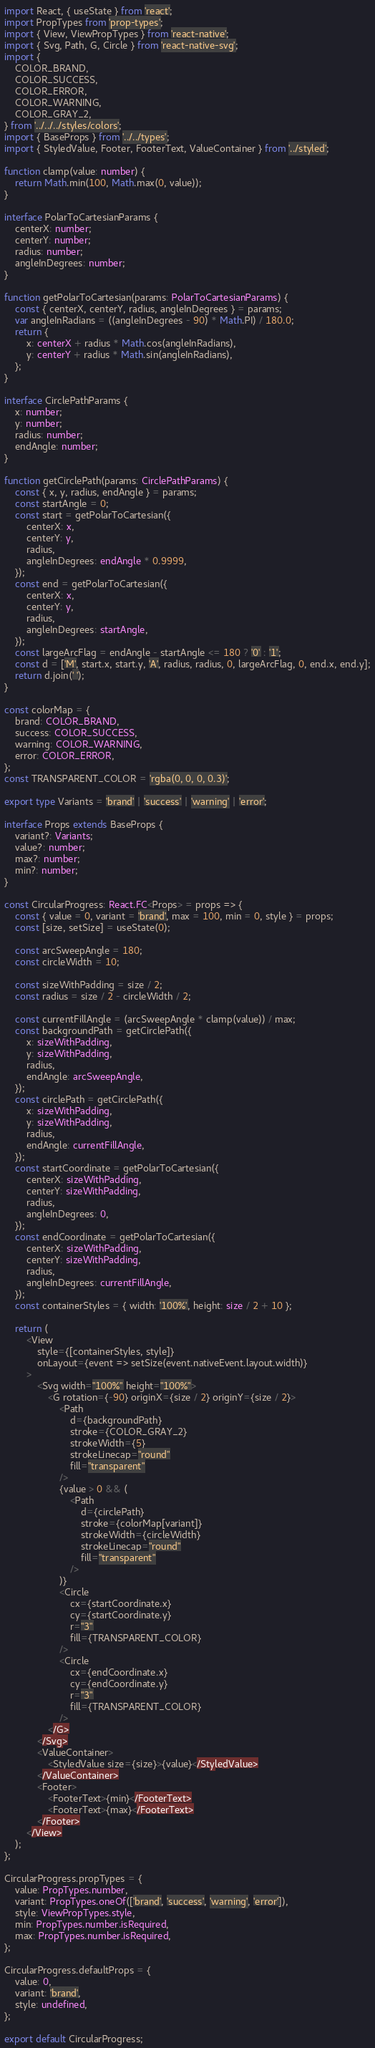<code> <loc_0><loc_0><loc_500><loc_500><_TypeScript_>import React, { useState } from 'react';
import PropTypes from 'prop-types';
import { View, ViewPropTypes } from 'react-native';
import { Svg, Path, G, Circle } from 'react-native-svg';
import {
    COLOR_BRAND,
    COLOR_SUCCESS,
    COLOR_ERROR,
    COLOR_WARNING,
    COLOR_GRAY_2,
} from '../../../styles/colors';
import { BaseProps } from '../../types';
import { StyledValue, Footer, FooterText, ValueContainer } from '../styled';

function clamp(value: number) {
    return Math.min(100, Math.max(0, value));
}

interface PolarToCartesianParams {
    centerX: number;
    centerY: number;
    radius: number;
    angleInDegrees: number;
}

function getPolarToCartesian(params: PolarToCartesianParams) {
    const { centerX, centerY, radius, angleInDegrees } = params;
    var angleInRadians = ((angleInDegrees - 90) * Math.PI) / 180.0;
    return {
        x: centerX + radius * Math.cos(angleInRadians),
        y: centerY + radius * Math.sin(angleInRadians),
    };
}

interface CirclePathParams {
    x: number;
    y: number;
    radius: number;
    endAngle: number;
}

function getCirclePath(params: CirclePathParams) {
    const { x, y, radius, endAngle } = params;
    const startAngle = 0;
    const start = getPolarToCartesian({
        centerX: x,
        centerY: y,
        radius,
        angleInDegrees: endAngle * 0.9999,
    });
    const end = getPolarToCartesian({
        centerX: x,
        centerY: y,
        radius,
        angleInDegrees: startAngle,
    });
    const largeArcFlag = endAngle - startAngle <= 180 ? '0' : '1';
    const d = ['M', start.x, start.y, 'A', radius, radius, 0, largeArcFlag, 0, end.x, end.y];
    return d.join(' ');
}

const colorMap = {
    brand: COLOR_BRAND,
    success: COLOR_SUCCESS,
    warning: COLOR_WARNING,
    error: COLOR_ERROR,
};
const TRANSPARENT_COLOR = 'rgba(0, 0, 0, 0.3)';

export type Variants = 'brand' | 'success' | 'warning' | 'error';

interface Props extends BaseProps {
    variant?: Variants;
    value?: number;
    max?: number;
    min?: number;
}

const CircularProgress: React.FC<Props> = props => {
    const { value = 0, variant = 'brand', max = 100, min = 0, style } = props;
    const [size, setSize] = useState(0);

    const arcSweepAngle = 180;
    const circleWidth = 10;

    const sizeWithPadding = size / 2;
    const radius = size / 2 - circleWidth / 2;

    const currentFillAngle = (arcSweepAngle * clamp(value)) / max;
    const backgroundPath = getCirclePath({
        x: sizeWithPadding,
        y: sizeWithPadding,
        radius,
        endAngle: arcSweepAngle,
    });
    const circlePath = getCirclePath({
        x: sizeWithPadding,
        y: sizeWithPadding,
        radius,
        endAngle: currentFillAngle,
    });
    const startCoordinate = getPolarToCartesian({
        centerX: sizeWithPadding,
        centerY: sizeWithPadding,
        radius,
        angleInDegrees: 0,
    });
    const endCoordinate = getPolarToCartesian({
        centerX: sizeWithPadding,
        centerY: sizeWithPadding,
        radius,
        angleInDegrees: currentFillAngle,
    });
    const containerStyles = { width: '100%', height: size / 2 + 10 };

    return (
        <View
            style={[containerStyles, style]}
            onLayout={event => setSize(event.nativeEvent.layout.width)}
        >
            <Svg width="100%" height="100%">
                <G rotation={-90} originX={size / 2} originY={size / 2}>
                    <Path
                        d={backgroundPath}
                        stroke={COLOR_GRAY_2}
                        strokeWidth={5}
                        strokeLinecap="round"
                        fill="transparent"
                    />
                    {value > 0 && (
                        <Path
                            d={circlePath}
                            stroke={colorMap[variant]}
                            strokeWidth={circleWidth}
                            strokeLinecap="round"
                            fill="transparent"
                        />
                    )}
                    <Circle
                        cx={startCoordinate.x}
                        cy={startCoordinate.y}
                        r="3"
                        fill={TRANSPARENT_COLOR}
                    />
                    <Circle
                        cx={endCoordinate.x}
                        cy={endCoordinate.y}
                        r="3"
                        fill={TRANSPARENT_COLOR}
                    />
                </G>
            </Svg>
            <ValueContainer>
                <StyledValue size={size}>{value}</StyledValue>
            </ValueContainer>
            <Footer>
                <FooterText>{min}</FooterText>
                <FooterText>{max}</FooterText>
            </Footer>
        </View>
    );
};

CircularProgress.propTypes = {
    value: PropTypes.number,
    variant: PropTypes.oneOf(['brand', 'success', 'warning', 'error']),
    style: ViewPropTypes.style,
    min: PropTypes.number.isRequired,
    max: PropTypes.number.isRequired,
};

CircularProgress.defaultProps = {
    value: 0,
    variant: 'brand',
    style: undefined,
};

export default CircularProgress;
</code> 